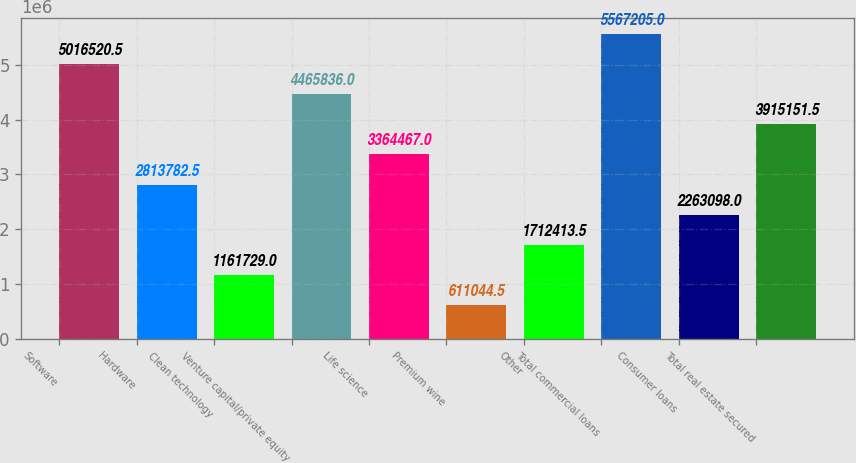Convert chart. <chart><loc_0><loc_0><loc_500><loc_500><bar_chart><fcel>Software<fcel>Hardware<fcel>Clean technology<fcel>Venture capital/private equity<fcel>Life science<fcel>Premium wine<fcel>Other<fcel>Total commercial loans<fcel>Consumer loans<fcel>Total real estate secured<nl><fcel>5.01652e+06<fcel>2.81378e+06<fcel>1.16173e+06<fcel>4.46584e+06<fcel>3.36447e+06<fcel>611044<fcel>1.71241e+06<fcel>5.5672e+06<fcel>2.2631e+06<fcel>3.91515e+06<nl></chart> 